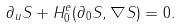<formula> <loc_0><loc_0><loc_500><loc_500>\partial _ { u } S + H ^ { e } _ { 0 } ( \partial _ { 0 } S , \nabla S ) = 0 .</formula> 